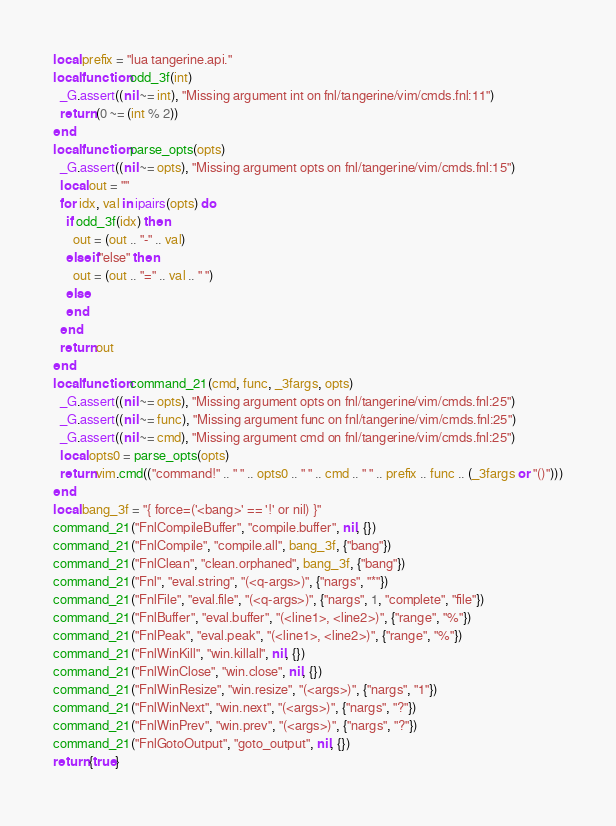Convert code to text. <code><loc_0><loc_0><loc_500><loc_500><_Lua_>local prefix = "lua tangerine.api."
local function odd_3f(int)
  _G.assert((nil ~= int), "Missing argument int on fnl/tangerine/vim/cmds.fnl:11")
  return (0 ~= (int % 2))
end
local function parse_opts(opts)
  _G.assert((nil ~= opts), "Missing argument opts on fnl/tangerine/vim/cmds.fnl:15")
  local out = ""
  for idx, val in ipairs(opts) do
    if odd_3f(idx) then
      out = (out .. "-" .. val)
    elseif "else" then
      out = (out .. "=" .. val .. " ")
    else
    end
  end
  return out
end
local function command_21(cmd, func, _3fargs, opts)
  _G.assert((nil ~= opts), "Missing argument opts on fnl/tangerine/vim/cmds.fnl:25")
  _G.assert((nil ~= func), "Missing argument func on fnl/tangerine/vim/cmds.fnl:25")
  _G.assert((nil ~= cmd), "Missing argument cmd on fnl/tangerine/vim/cmds.fnl:25")
  local opts0 = parse_opts(opts)
  return vim.cmd(("command!" .. " " .. opts0 .. " " .. cmd .. " " .. prefix .. func .. (_3fargs or "()")))
end
local bang_3f = "{ force=('<bang>' == '!' or nil) }"
command_21("FnlCompileBuffer", "compile.buffer", nil, {})
command_21("FnlCompile", "compile.all", bang_3f, {"bang"})
command_21("FnlClean", "clean.orphaned", bang_3f, {"bang"})
command_21("Fnl", "eval.string", "(<q-args>)", {"nargs", "*"})
command_21("FnlFile", "eval.file", "(<q-args>)", {"nargs", 1, "complete", "file"})
command_21("FnlBuffer", "eval.buffer", "(<line1>, <line2>)", {"range", "%"})
command_21("FnlPeak", "eval.peak", "(<line1>, <line2>)", {"range", "%"})
command_21("FnlWinKill", "win.killall", nil, {})
command_21("FnlWinClose", "win.close", nil, {})
command_21("FnlWinResize", "win.resize", "(<args>)", {"nargs", "1"})
command_21("FnlWinNext", "win.next", "(<args>)", {"nargs", "?"})
command_21("FnlWinPrev", "win.prev", "(<args>)", {"nargs", "?"})
command_21("FnlGotoOutput", "goto_output", nil, {})
return {true}
</code> 